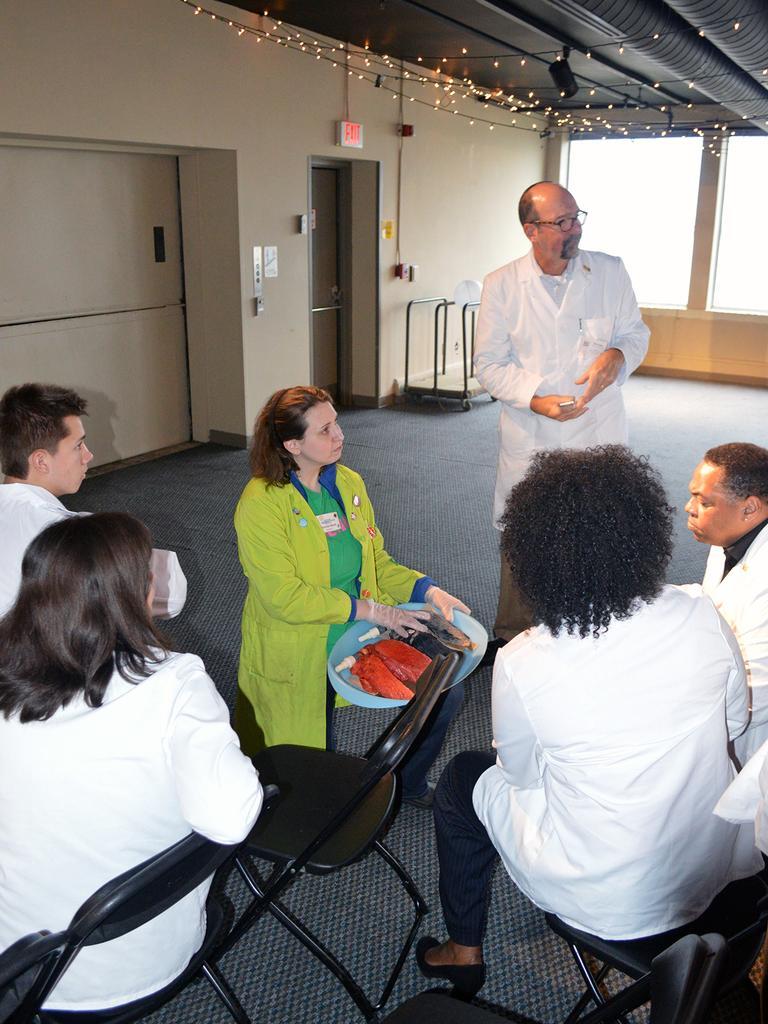Describe this image in one or two sentences. In this image at the bottom there are few people sitting on chair, one woman sitting in squat position holding an object, another man standing in front of them, at the top there are the roofs, on which there are some lighting, in the middle there are doors, ball and a stand, window. 